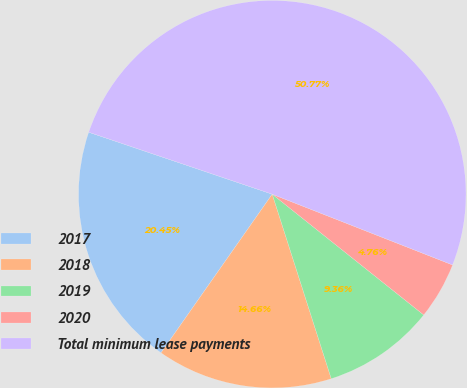<chart> <loc_0><loc_0><loc_500><loc_500><pie_chart><fcel>2017<fcel>2018<fcel>2019<fcel>2020<fcel>Total minimum lease payments<nl><fcel>20.45%<fcel>14.66%<fcel>9.36%<fcel>4.76%<fcel>50.77%<nl></chart> 